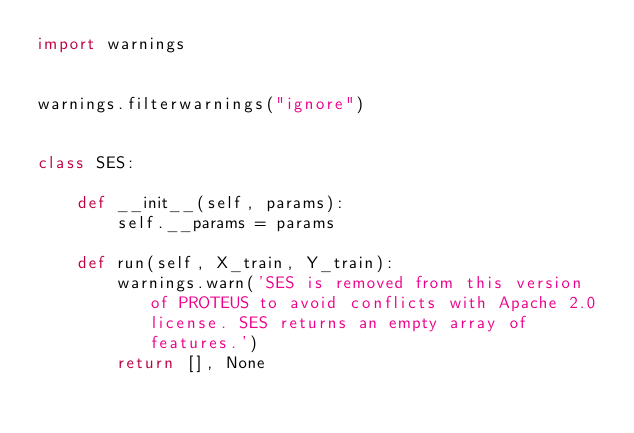<code> <loc_0><loc_0><loc_500><loc_500><_Python_>import warnings


warnings.filterwarnings("ignore")


class SES:

    def __init__(self, params):
        self.__params = params

    def run(self, X_train, Y_train):
        warnings.warn('SES is removed from this version of PROTEUS to avoid conflicts with Apache 2.0 license. SES returns an empty array of features.')
        return [], None
</code> 